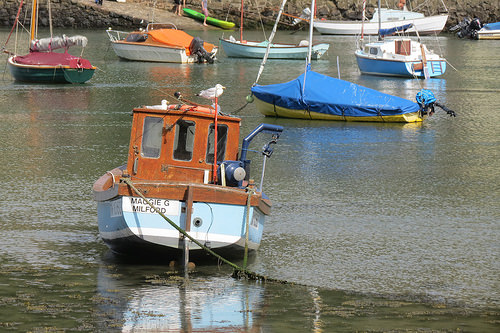<image>
Can you confirm if the boat is on the water? Yes. Looking at the image, I can see the boat is positioned on top of the water, with the water providing support. 